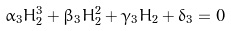Convert formula to latex. <formula><loc_0><loc_0><loc_500><loc_500>\alpha _ { 3 } H _ { 2 } ^ { 3 } + \beta _ { 3 } H _ { 2 } ^ { 2 } + \gamma _ { 3 } H _ { 2 } + \delta _ { 3 } = 0</formula> 